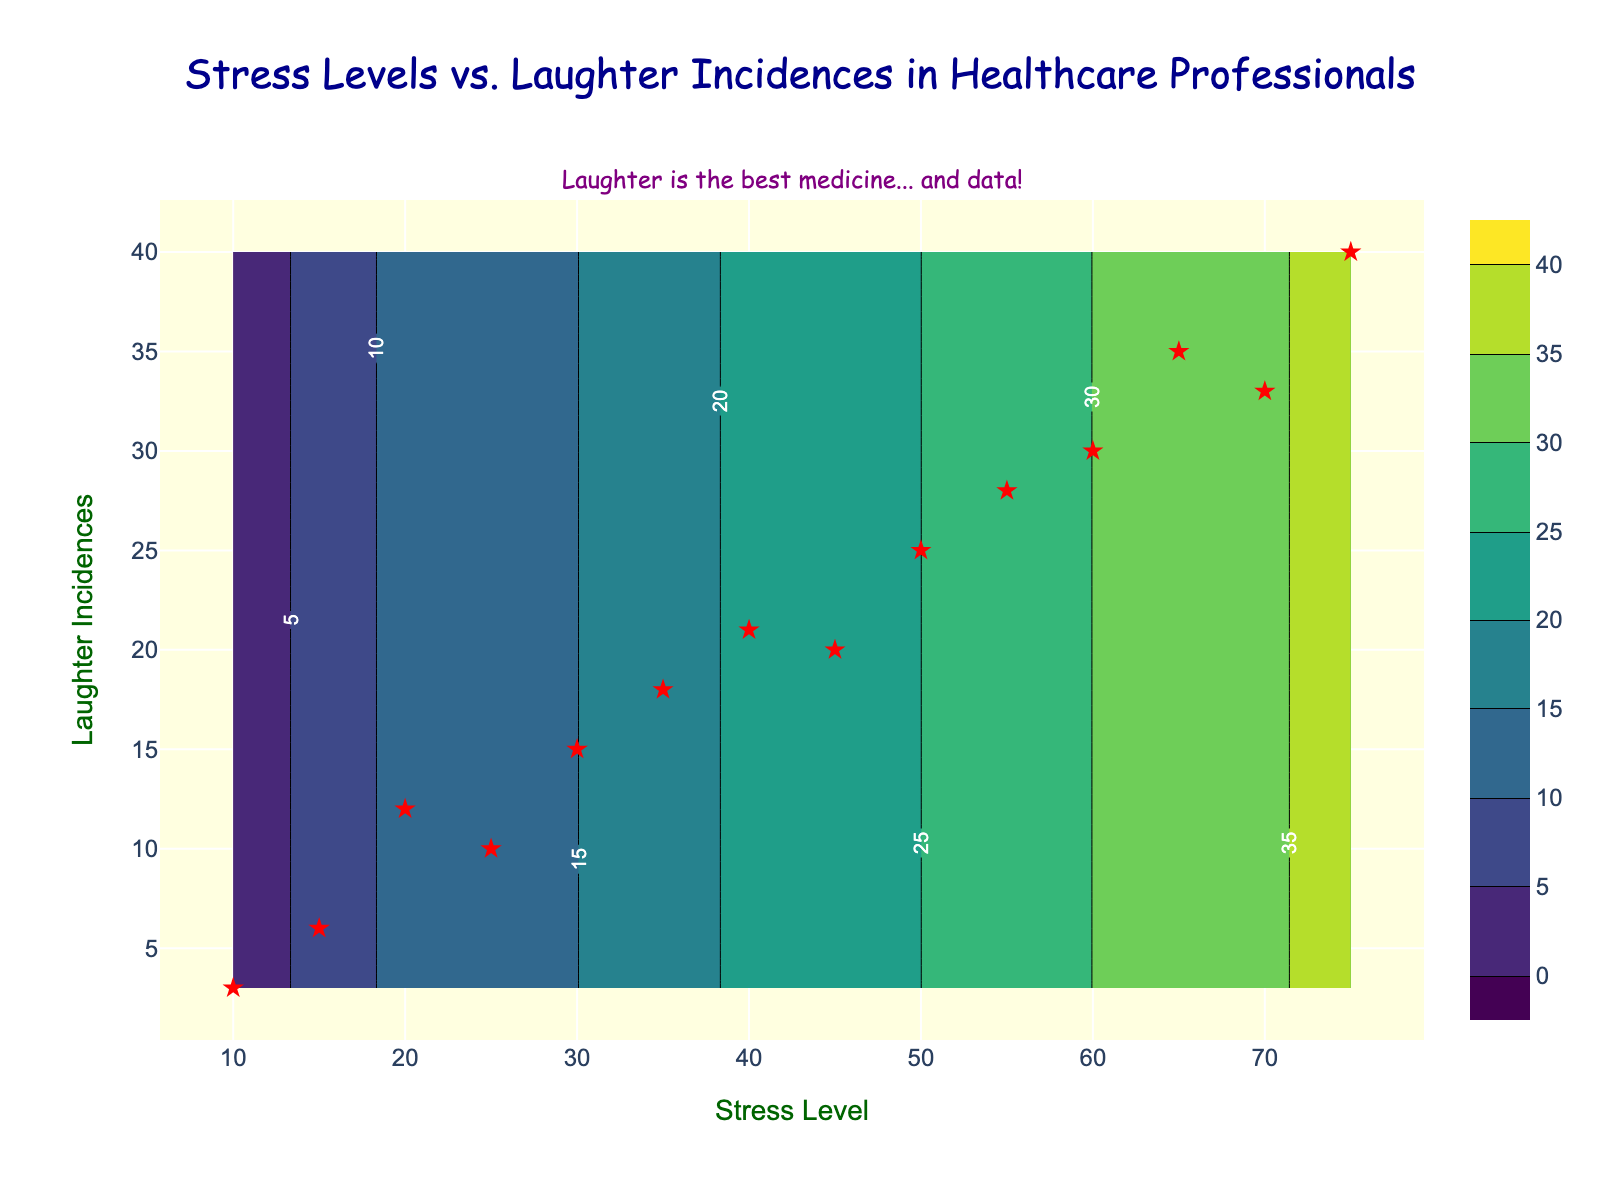What's the title of the figure? The title is usually placed prominently at the top of the figure. In this case, it reads "Stress Levels vs. Laughter Incidences in Healthcare Professionals" in a styled font.
Answer: Stress Levels vs. Laughter Incidences in Healthcare Professionals What are the labels for the x-axis and y-axis? The labels for the axes are usually positioned near their respective axes. Here, the x-axis label is "Stress Level" and the y-axis label is "Laughter Incidences," both in a green-colored font.
Answer: Stress Level and Laughter Incidences How many data points are depicted as red stars on the plot? The data points are marked as red stars on the plot. By counting these stars, you find that there are 14 data points.
Answer: 14 What is the highest value for laughter incidences recorded in the data points? The laughter incidences reach their peak at the highest value represented by red stars on the plot. This top value is marked at 40.
Answer: 40 At what stress level are most laughter incidences reported? By looking at the highest point on the y-axis that intersects with the x-axis's stress level, most laughter incidences are recorded at a stress level of 75.
Answer: 75 Comparing stress levels 45 and 55, which one has more laughter incidences? Locate the red stars at the stress levels of 45 and 55 on the x-axis and compare their positions on the y-axis. The laughter incidences at 55 are 28, while at 45, they are 20. Thus, 55 has more laughter incidences.
Answer: 55 What is the logical peak value on the contour plot between 0 and 40 for laughter incidences? The contour plot's levels start at 0 and end at 40. The peak value within this range is the maximum value labeled, which is 40.
Answer: 40 How does the trend appear between stress levels and laughter incidences from 10 to 75? By tracing the red stars from the minimum stress level of 10 to the maximum of 75, you observe that as stress levels increase, laughter incidences initially rise, showing a positive correlation, and reach a peak before slightly declining.
Answer: Positive correlation, peaking around 75 What can you infer from the humor annotation at the top of the plot? The annotation, "Laughter is the best medicine... and data!" suggests the plot's theme is both insightful and light-hearted, emphasizing the positive impact of laughter on stress in a humorous way.
Answer: Laughter is beneficial for stress levels What's the median value of laughter incidences for stress levels up to 55? Listing the incidences for stress levels up to 55 gives: 3, 6, 12, 10, 15, 18, 21, and 20. Arranging these values: 3, 6, 10, 12, 15, 18, 20, 21. The median is the average of the 4th and 5th values: (12 + 15)/2 = 13.5.
Answer: 13.5 